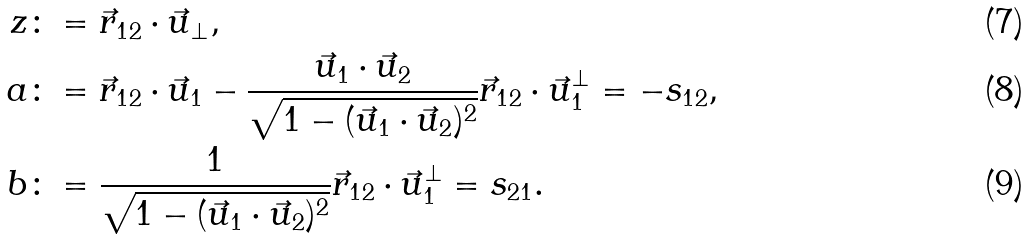Convert formula to latex. <formula><loc_0><loc_0><loc_500><loc_500>z & \colon = \vec { r } _ { 1 2 } \cdot \vec { u } _ { \perp } , \\ a & \colon = \vec { r } _ { 1 2 } \cdot \vec { u } _ { 1 } - \frac { \vec { u } _ { 1 } \cdot \vec { u } _ { 2 } } { \sqrt { 1 - ( \vec { u } _ { 1 } \cdot \vec { u } _ { 2 } ) ^ { 2 } } } \vec { r } _ { 1 2 } \cdot \vec { u } _ { 1 } ^ { \perp } = - s _ { 1 2 } , \\ b & \colon = \frac { 1 } { \sqrt { 1 - ( \vec { u } _ { 1 } \cdot \vec { u } _ { 2 } ) ^ { 2 } } } \vec { r } _ { 1 2 } \cdot \vec { u } _ { 1 } ^ { \perp } = s _ { 2 1 } .</formula> 